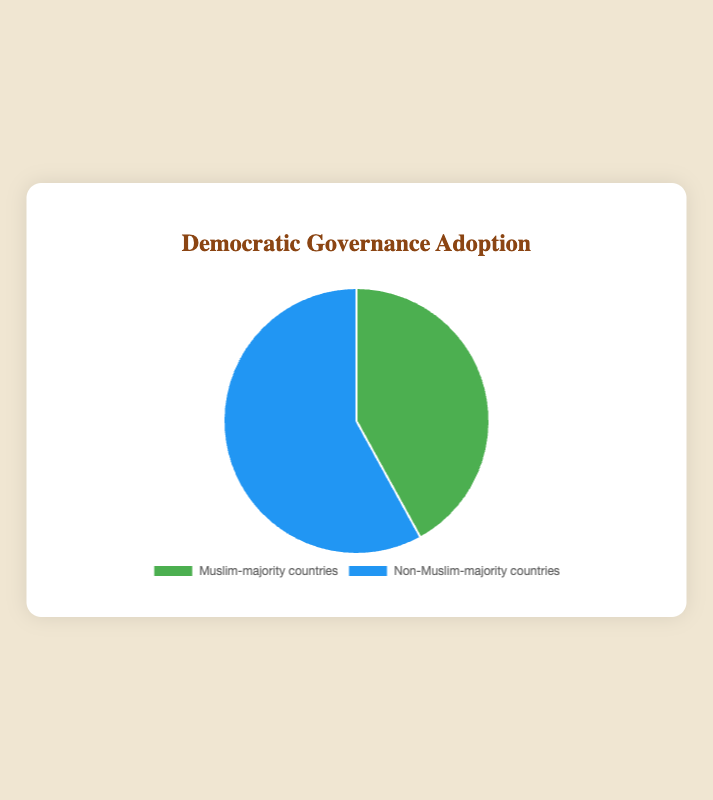What is the percentage of Muslim-majority countries adopting democratic governance systems? The pie chart shows two categories, one of which represents Muslim-majority countries adopting democratic governance systems. By looking at the corresponding slice of the pie, we see the percentage labeled for this category.
Answer: 42% What is the combined percentage of Muslim-majority and non-Muslim-majority countries adopting democratic governance systems? The pie chart segments add up to 100%. By summing the percentages of both Muslim-majority and non-Muslim-majority countries (42% + 58%), we can see that the combined total is 100%.
Answer: 100% How much higher is the percentage of non-Muslim-majority countries adopting democratic governance systems compared to Muslim-majority countries? By subtracting the percentage of Muslim-majority countries (42%) from non-Muslim-majority countries (58%), we can calculate the difference in percentages. The result is 58% - 42%.
Answer: 16% Which category occupies a greater slice of the pie chart, Muslim-majority or non-Muslim-majority countries adopting democratic governance systems? By visually inspecting the pie chart, we compare the sizes of the slices. The larger slice corresponds to non-Muslim-majority countries.
Answer: Non-Muslim-majority countries What is the ratio of non-Muslim-majority to Muslim-majority countries adopting democratic governance systems? The ratio can be calculated by dividing the percentage of non-Muslim-majority countries (58%) by the percentage of Muslim-majority countries (42%). This ratio is 58:42, which simplifies to approximately 1.38:1.
Answer: 1.38:1 What percentage of the chart is NOT occupied by Muslim-majority countries adopting democratic governance systems? Since the total percentage is 100%, subtracting the percentage of Muslim-majority countries (42%) from 100% gives us the part of the pie not occupied by this category.
Answer: 58% If the category of Muslim-majority countries adopting democratic governance systems increased by 10%, what would be the new percentage for both categories, assuming the total still equals 100%? If the Muslim-majority category increases by 10% to 52%, the non-Muslim-majority category would decrease by 10% to maintain the total of 100%, so it would be 48%.
Answer: Muslim-majority: 52%, Non-Muslim-majority: 48% What percentage of the pie chart is represented by the green color? By identifying the color associated with Muslim-majority countries (green) and checking its percentage in the figure, we see that this category represents 42% of the pie chart.
Answer: 42% How does the visual size of the slice representing Muslim-majority countries compare to the slice representing non-Muslim-majority countries? The slice representing Muslim-majority countries is visually smaller when compared to the slice representing non-Muslim-majority countries, based on their respective percentages (42% vs. 58%).
Answer: Smaller What percentage would need to shift from the non-Muslim-majority category to the Muslim-majority category for both to be equal? To equalize the percentages, each category should be 50%. Since Muslim-majority countries are at 42%, they need an additional 8%, which would be subtracted from the non-Muslim-majority category (58% - 8%).
Answer: 8% 